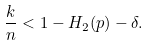<formula> <loc_0><loc_0><loc_500><loc_500>\frac { k } { n } < 1 - H _ { 2 } ( p ) - \delta .</formula> 